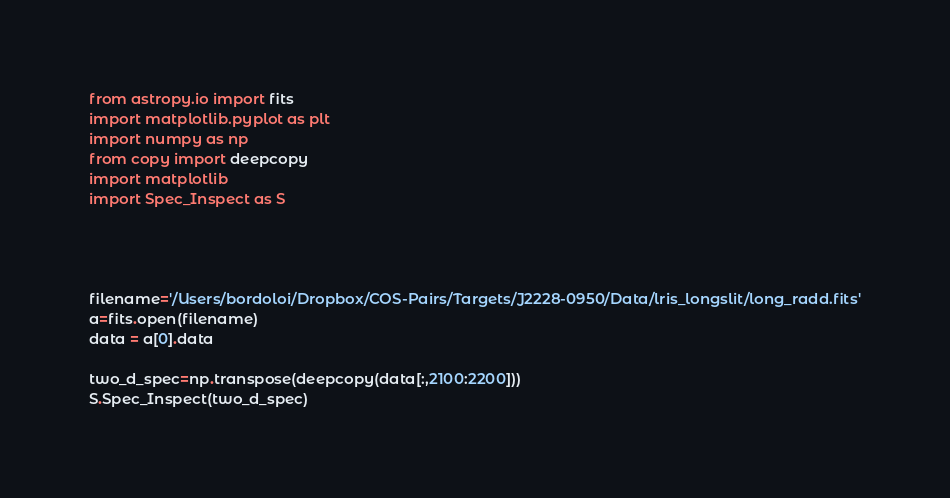<code> <loc_0><loc_0><loc_500><loc_500><_Python_>from astropy.io import fits
import matplotlib.pyplot as plt
import numpy as np
from copy import deepcopy
import matplotlib
import Spec_Inspect as S




filename='/Users/bordoloi/Dropbox/COS-Pairs/Targets/J2228-0950/Data/lris_longslit/long_radd.fits'
a=fits.open(filename)
data = a[0].data

two_d_spec=np.transpose(deepcopy(data[:,2100:2200]))
S.Spec_Inspect(two_d_spec)
</code> 